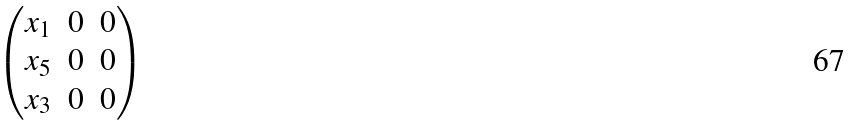Convert formula to latex. <formula><loc_0><loc_0><loc_500><loc_500>\begin{pmatrix} x _ { 1 } & 0 & 0 \\ x _ { 5 } & 0 & 0 \\ x _ { 3 } & 0 & 0 \end{pmatrix}</formula> 